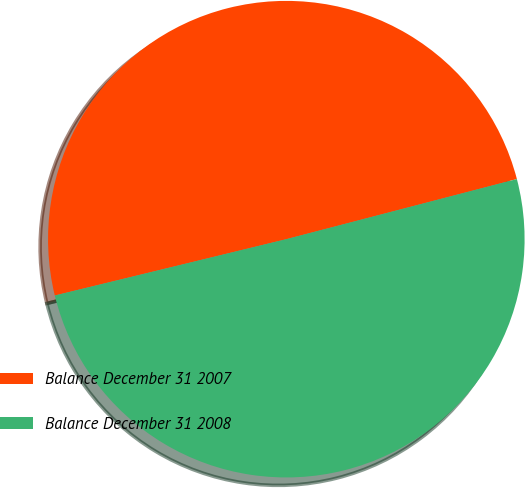Convert chart to OTSL. <chart><loc_0><loc_0><loc_500><loc_500><pie_chart><fcel>Balance December 31 2007<fcel>Balance December 31 2008<nl><fcel>49.74%<fcel>50.26%<nl></chart> 